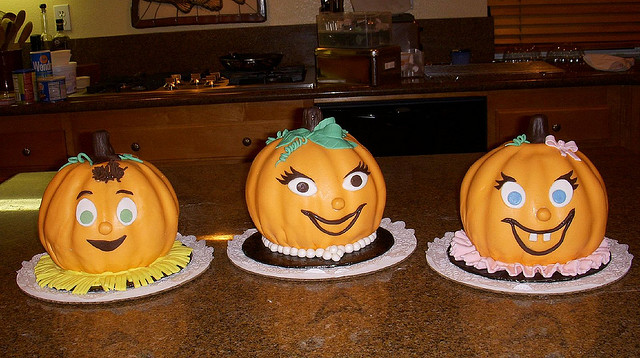Can you describe the decorations on these cakes? Certainly! The cakes are decorated to look like caricatured pumpkins with different expressions. They have large, friendly eyes, some with lashes, and smiles with white fondant teeth. Two wear playful bows, and the cake in the middle has a green stem headdress, suggesting they are part of a Halloween theme.  How might these cakes be used during Halloween? These cakes are perfect as centerpieces for a Halloween party. They can add a festive and whimsical touch to the table setting and are likely to be a conversation starter. Besides being decorative, they're also edible, so guests can enjoy a slice as part of the Halloween treats. 